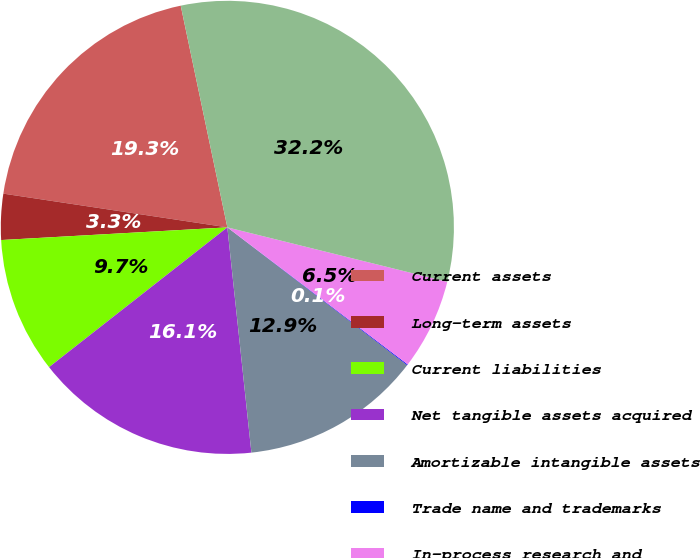<chart> <loc_0><loc_0><loc_500><loc_500><pie_chart><fcel>Current assets<fcel>Long-term assets<fcel>Current liabilities<fcel>Net tangible assets acquired<fcel>Amortizable intangible assets<fcel>Trade name and trademarks<fcel>In-process research and<fcel>Total purchase price<nl><fcel>19.32%<fcel>3.27%<fcel>9.69%<fcel>16.11%<fcel>12.9%<fcel>0.06%<fcel>6.48%<fcel>32.16%<nl></chart> 